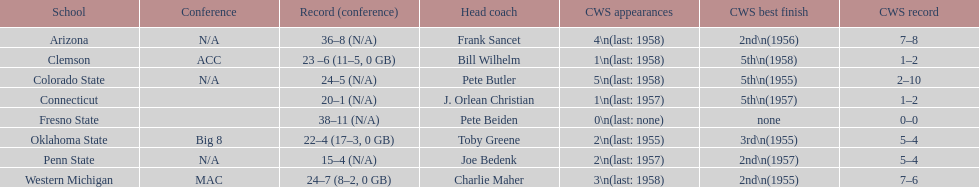Which team did not have more than 16 wins? Penn State. 